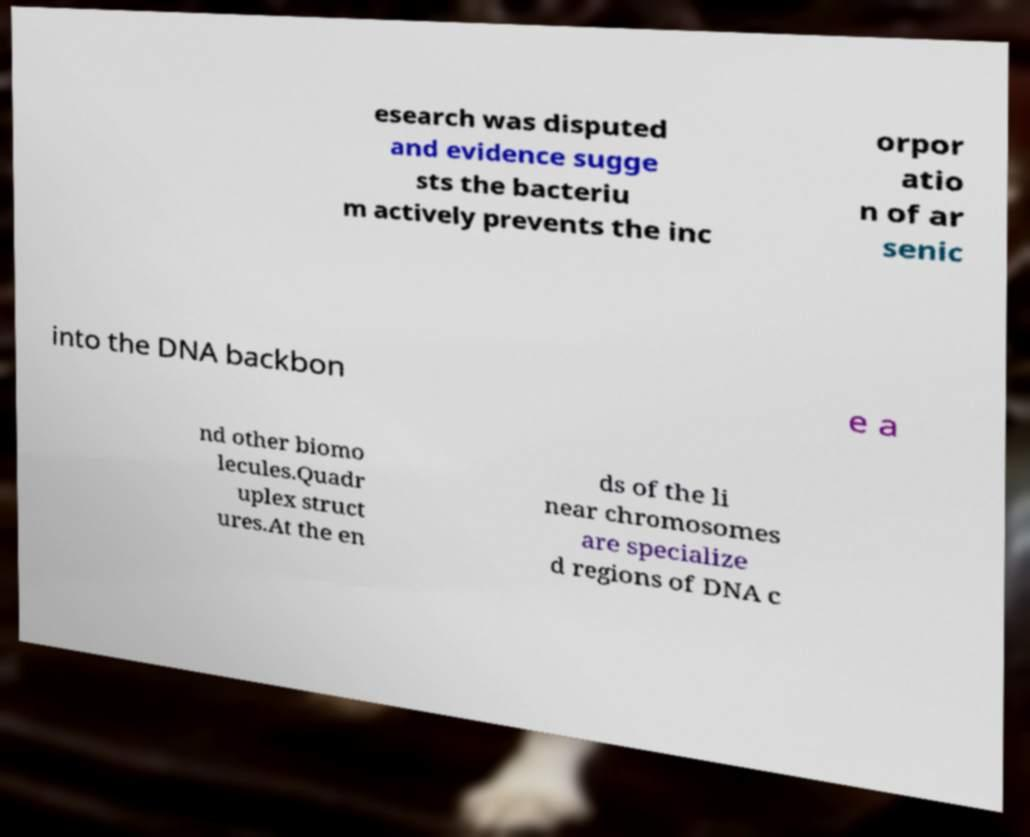Can you read and provide the text displayed in the image?This photo seems to have some interesting text. Can you extract and type it out for me? esearch was disputed and evidence sugge sts the bacteriu m actively prevents the inc orpor atio n of ar senic into the DNA backbon e a nd other biomo lecules.Quadr uplex struct ures.At the en ds of the li near chromosomes are specialize d regions of DNA c 